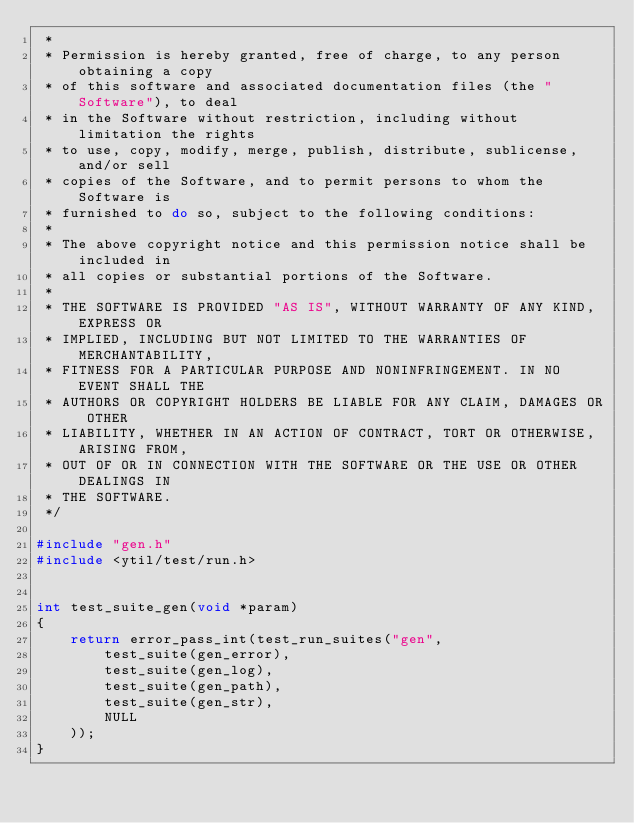Convert code to text. <code><loc_0><loc_0><loc_500><loc_500><_C_> *
 * Permission is hereby granted, free of charge, to any person obtaining a copy
 * of this software and associated documentation files (the "Software"), to deal
 * in the Software without restriction, including without limitation the rights
 * to use, copy, modify, merge, publish, distribute, sublicense, and/or sell
 * copies of the Software, and to permit persons to whom the Software is
 * furnished to do so, subject to the following conditions:
 *
 * The above copyright notice and this permission notice shall be included in
 * all copies or substantial portions of the Software.
 *
 * THE SOFTWARE IS PROVIDED "AS IS", WITHOUT WARRANTY OF ANY KIND, EXPRESS OR
 * IMPLIED, INCLUDING BUT NOT LIMITED TO THE WARRANTIES OF MERCHANTABILITY,
 * FITNESS FOR A PARTICULAR PURPOSE AND NONINFRINGEMENT. IN NO EVENT SHALL THE
 * AUTHORS OR COPYRIGHT HOLDERS BE LIABLE FOR ANY CLAIM, DAMAGES OR OTHER
 * LIABILITY, WHETHER IN AN ACTION OF CONTRACT, TORT OR OTHERWISE, ARISING FROM,
 * OUT OF OR IN CONNECTION WITH THE SOFTWARE OR THE USE OR OTHER DEALINGS IN
 * THE SOFTWARE.
 */

#include "gen.h"
#include <ytil/test/run.h>


int test_suite_gen(void *param)
{
    return error_pass_int(test_run_suites("gen",
        test_suite(gen_error),
        test_suite(gen_log),
        test_suite(gen_path),
        test_suite(gen_str),
        NULL
    ));
}
</code> 